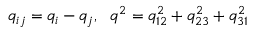Convert formula to latex. <formula><loc_0><loc_0><loc_500><loc_500>q _ { i j } = q _ { i } - q _ { j } , \ \ q ^ { 2 } = q _ { 1 2 } ^ { 2 } + q _ { 2 3 } ^ { 2 } + q _ { 3 1 } ^ { 2 }</formula> 